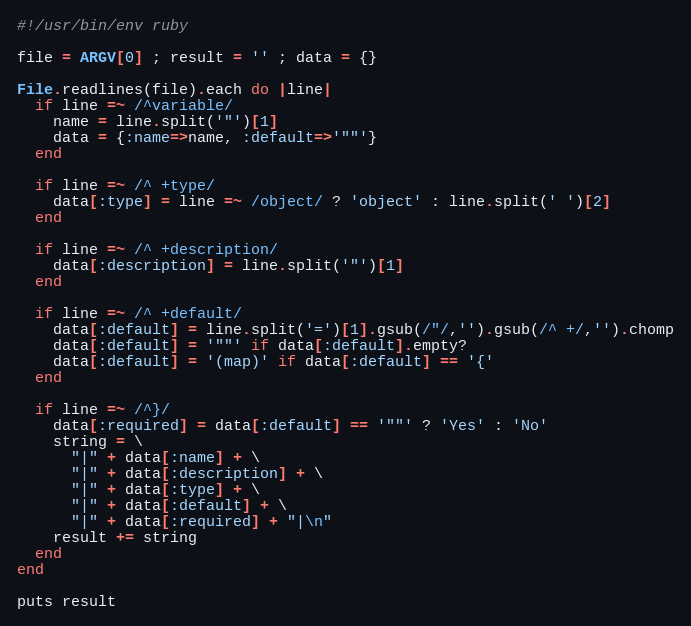<code> <loc_0><loc_0><loc_500><loc_500><_Ruby_>#!/usr/bin/env ruby

file = ARGV[0] ; result = '' ; data = {}

File.readlines(file).each do |line|
  if line =~ /^variable/
    name = line.split('"')[1]
    data = {:name=>name, :default=>'""'}
  end

  if line =~ /^ +type/
    data[:type] = line =~ /object/ ? 'object' : line.split(' ')[2]
  end

  if line =~ /^ +description/
    data[:description] = line.split('"')[1]
  end

  if line =~ /^ +default/
    data[:default] = line.split('=')[1].gsub(/"/,'').gsub(/^ +/,'').chomp
    data[:default] = '""' if data[:default].empty?
    data[:default] = '(map)' if data[:default] == '{'
  end

  if line =~ /^}/
    data[:required] = data[:default] == '""' ? 'Yes' : 'No'
    string = \
      "|" + data[:name] + \
      "|" + data[:description] + \
      "|" + data[:type] + \
      "|" + data[:default] + \
      "|" + data[:required] + "|\n" 
    result += string
  end
end

puts result
</code> 